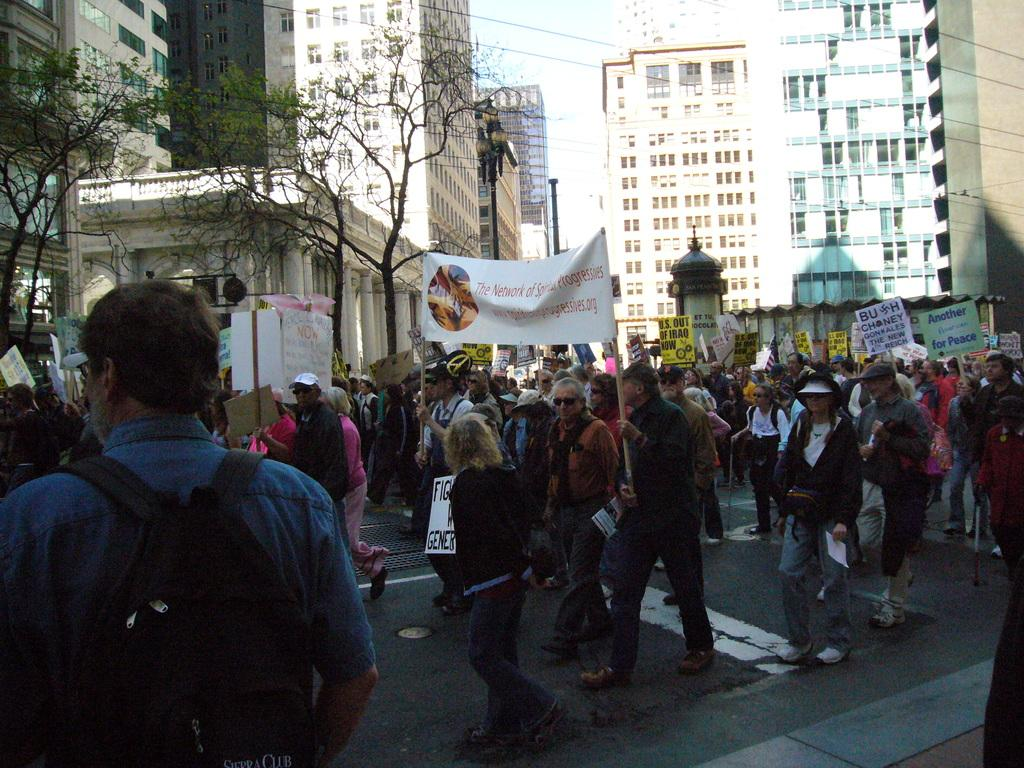What are the people in the image doing? The people in the image are walking in the center of the image. What can be seen in the distance behind the people? There are buildings and trees in the background of the image. What is at the bottom of the image? There is a road at the bottom of the image. What type of toad can be seen hopping on the road in the image? There is no toad present in the image; it only features people walking, buildings, trees, and a road. 